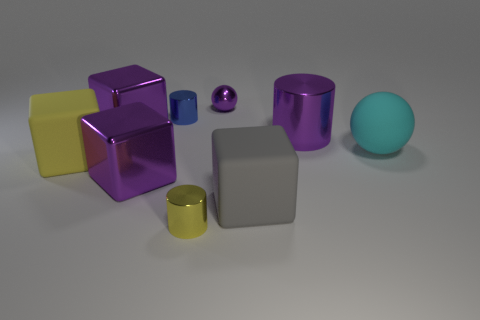Can you infer the size of these objects? Without a direct point of reference in the image, it's challenging to infer the precise size of these objects. However, based on their relative proportions and the assumption that the scene mimics real-world dimensions, we might guess that the cylinders and cubes are akin in size to small household objects, potentially ranging from a few inches to a foot in height and length. 